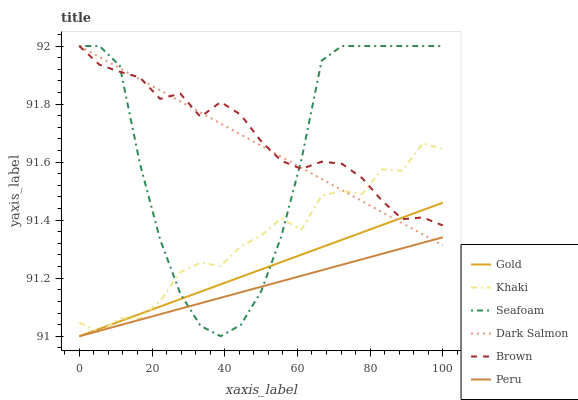Does Peru have the minimum area under the curve?
Answer yes or no. Yes. Does Brown have the maximum area under the curve?
Answer yes or no. Yes. Does Khaki have the minimum area under the curve?
Answer yes or no. No. Does Khaki have the maximum area under the curve?
Answer yes or no. No. Is Gold the smoothest?
Answer yes or no. Yes. Is Seafoam the roughest?
Answer yes or no. Yes. Is Khaki the smoothest?
Answer yes or no. No. Is Khaki the roughest?
Answer yes or no. No. Does Khaki have the lowest value?
Answer yes or no. No. Does Dark Salmon have the highest value?
Answer yes or no. Yes. Does Khaki have the highest value?
Answer yes or no. No. Is Peru less than Brown?
Answer yes or no. Yes. Is Brown greater than Peru?
Answer yes or no. Yes. Does Peru intersect Brown?
Answer yes or no. No. 